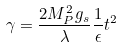Convert formula to latex. <formula><loc_0><loc_0><loc_500><loc_500>\gamma = \frac { 2 M _ { P } ^ { 2 } g _ { s } } { \lambda } \frac { 1 } { \epsilon } t ^ { 2 }</formula> 